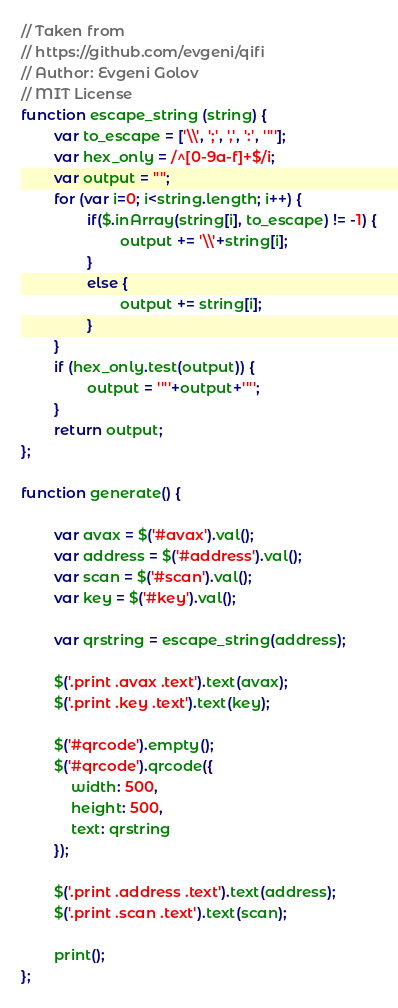Convert code to text. <code><loc_0><loc_0><loc_500><loc_500><_JavaScript_>// Taken from
// https://github.com/evgeni/qifi
// Author: Evgeni Golov
// MIT License
function escape_string (string) {
		var to_escape = ['\\', ';', ',', ':', '"'];
		var hex_only = /^[0-9a-f]+$/i;
		var output = "";
		for (var i=0; i<string.length; i++) {
				if($.inArray(string[i], to_escape) != -1) {
						output += '\\'+string[i];
				}
				else {
						output += string[i];
				}
		}
		if (hex_only.test(output)) {
				output = '"'+output+'"';
		}
		return output;
};
        
function generate() {

		var avax = $('#avax').val();
		var address = $('#address').val();
		var scan = $('#scan').val();
		var key = $('#key').val();

		var qrstring = escape_string(address);

		$('.print .avax .text').text(avax);
		$('.print .key .text').text(key);

		$('#qrcode').empty();
		$('#qrcode').qrcode({
			width: 500,
			height: 500,
			text: qrstring
		});
		
		$('.print .address .text').text(address);
		$('.print .scan .text').text(scan);

		print(); 
};
</code> 